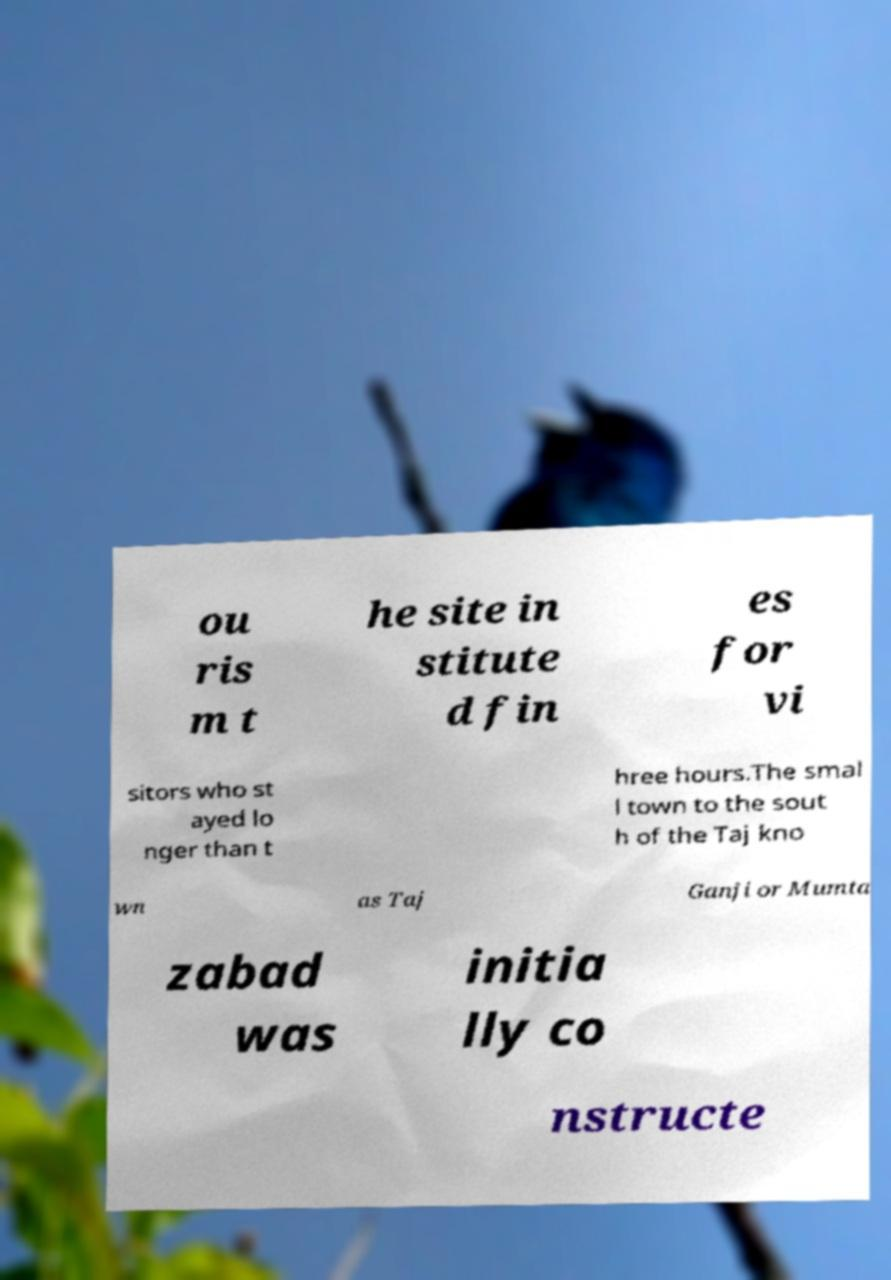Could you extract and type out the text from this image? ou ris m t he site in stitute d fin es for vi sitors who st ayed lo nger than t hree hours.The smal l town to the sout h of the Taj kno wn as Taj Ganji or Mumta zabad was initia lly co nstructe 